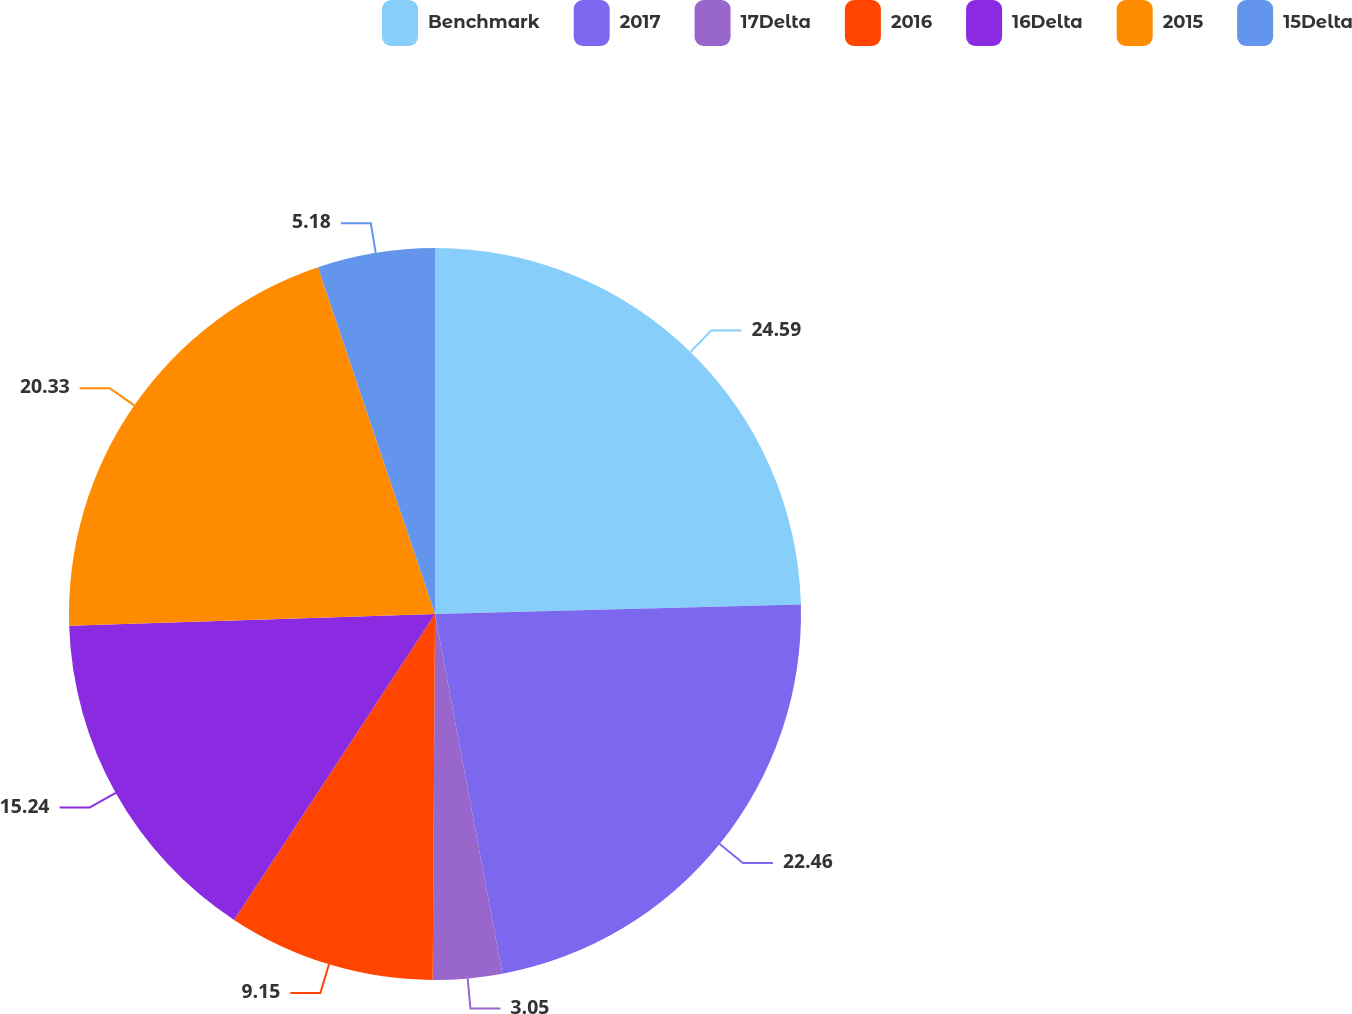<chart> <loc_0><loc_0><loc_500><loc_500><pie_chart><fcel>Benchmark<fcel>2017<fcel>17Delta<fcel>2016<fcel>16Delta<fcel>2015<fcel>15Delta<nl><fcel>24.59%<fcel>22.46%<fcel>3.05%<fcel>9.15%<fcel>15.24%<fcel>20.33%<fcel>5.18%<nl></chart> 